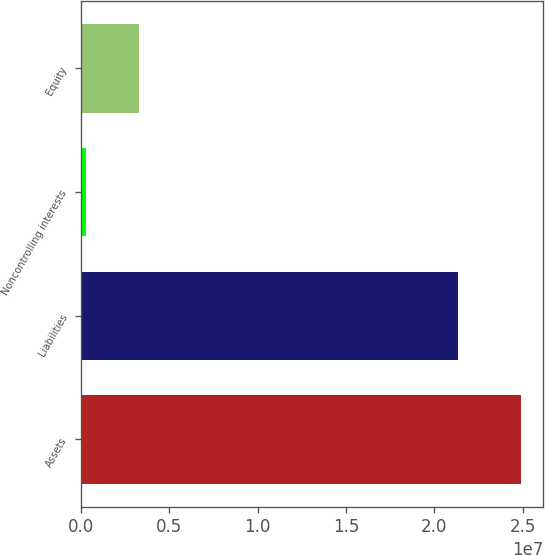Convert chart. <chart><loc_0><loc_0><loc_500><loc_500><bar_chart><fcel>Assets<fcel>Liabilities<fcel>Noncontrolling interests<fcel>Equity<nl><fcel>2.4926e+07<fcel>2.1357e+07<fcel>265000<fcel>3.304e+06<nl></chart> 